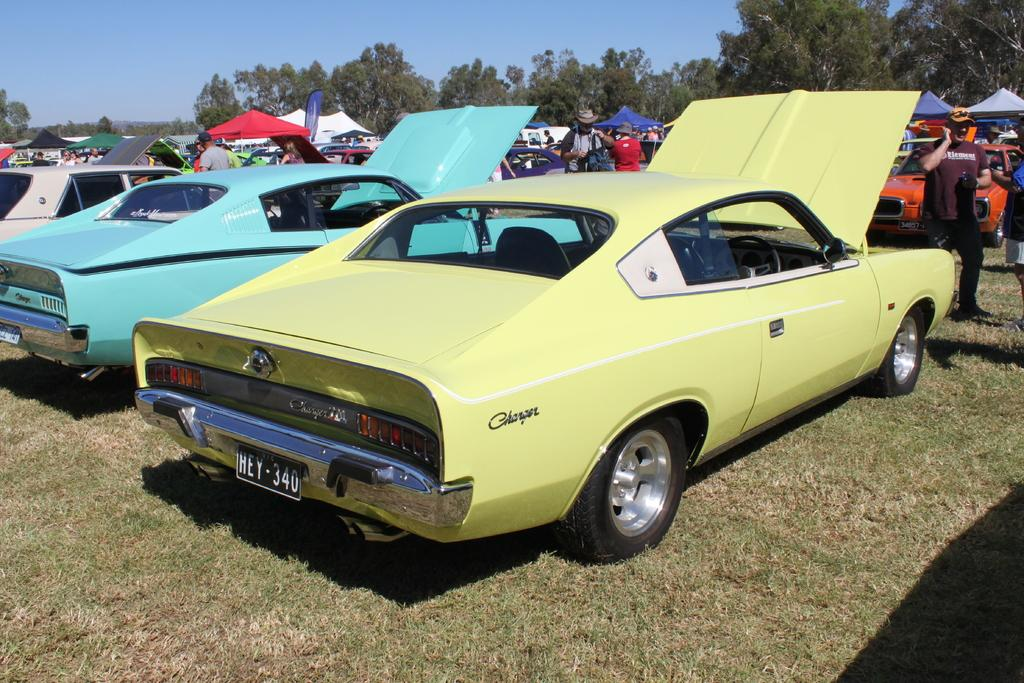What type of vehicles can be seen in the image? There are cars in the image. Who or what else is present in the image? There are people and tents in the image. What can be seen in the background of the image? There are trees and the sky visible in the background of the image. What is the ground made of in the image? There is grass at the bottom of the image. What time does the clock show in the image? There is no clock present in the image. Is there a minister in the image? There is no minister present in the image. 